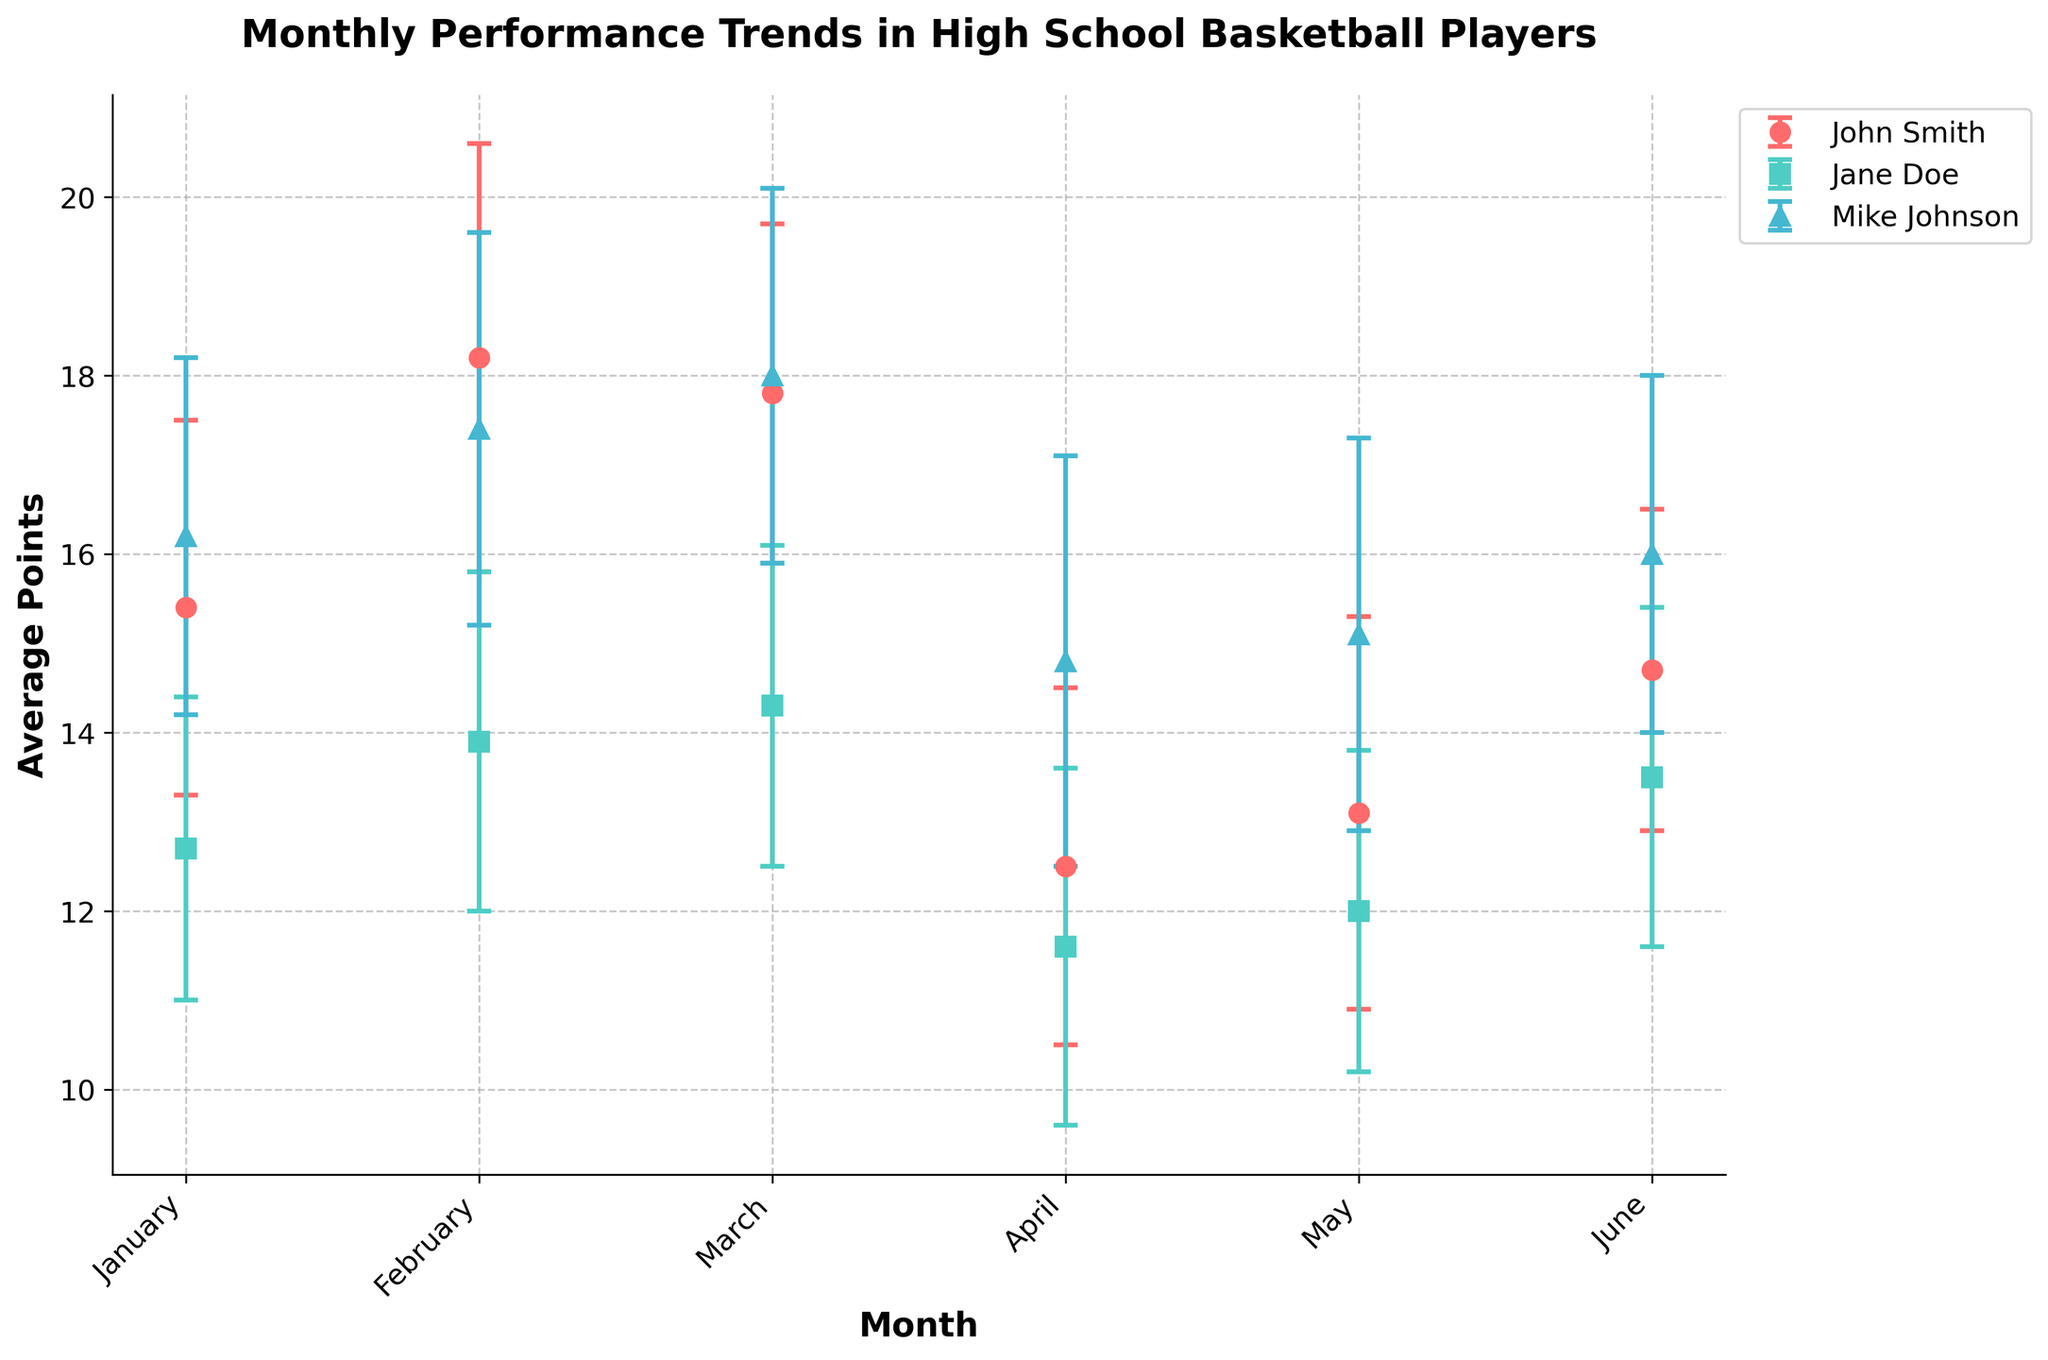What's the title of the figure? The title is the text at the top of the figure that summarizes the content being visualized.
Answer: Monthly Performance Trends in High School Basketball Players What is the average points scored by John Smith in February? Look for John Smith's data in the month of February and find the average points scored.
Answer: 18.2 Which player has the highest average points scored in January? Compare the average points scored by each player in January and identify the highest.
Answer: Mike Johnson What is the range of average points scored by Jane Doe from January to June? Calculate the difference between the highest and lowest average points scored by Jane Doe from January to June. The highest value is 14.3 in March and the lowest value is 11.6 in April. The range = 14.3 - 11.6.
Answer: 2.7 In which month does John Smith show the highest standard deviation in points? Refer to John Smith's Points_StdDev for each month and identify the month with the highest value.
Answer: May Between February and March, which player shows more consistency in points, considering their standard deviations? Analyze the Points_StdDev for each player between February and March. The player with the lower value indicates higher consistency. For example, John Smith has a StdDev of 2.4 in February and 1.9 in March, while Jane Doe has 1.9 and 1.8 respectively. Compare these values across players.
Answer: Jane Doe How does the average points scored by Mike Johnson in April compare to his average points in June? Look at Mike Johnson's average points scored in both April and June, then calculate the difference. April: 14.8, June: 16.0. Difference = 16.0 - 14.8.
Answer: 1.2 more points in June Who has the highest average points in March and what is the value? Compare the average points scored by each player in March and identify the highest along with the value.
Answer: Mike Johnson with 18.0 points 